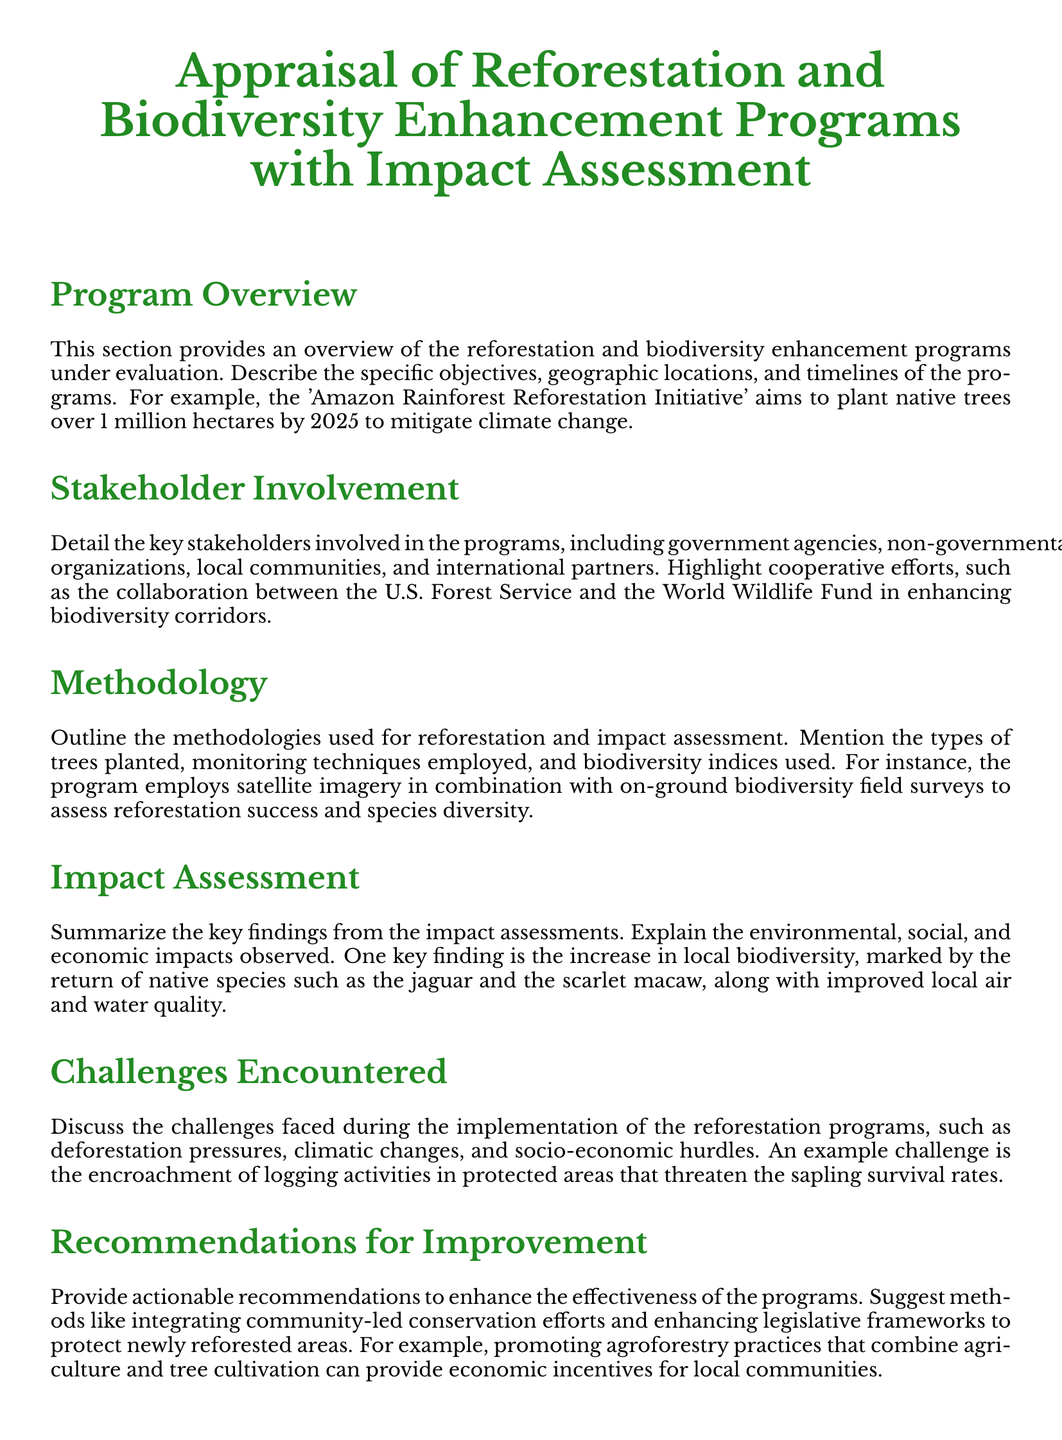What is the main objective of the Amazon Rainforest Reforestation Initiative? The main objective is to plant native trees over 1 million hectares by 2025 to mitigate climate change.
Answer: plant native trees over 1 million hectares by 2025 Who are the stakeholders mentioned in the programs? Key stakeholders include government agencies, non-governmental organizations, local communities, and international partners.
Answer: government agencies, non-governmental organizations, local communities, international partners What methodology involves satellite imagery? The methodology that involves satellite imagery is to assess reforestation success and species diversity.
Answer: assess reforestation success and species diversity Which native species returned as a key finding? The return of native species such as the jaguar and the scarlet macaw was a key finding.
Answer: jaguar and the scarlet macaw What challenge is mentioned regarding logging activities? The challenge mentioned is the encroachment of logging activities in protected areas that threaten sapling survival rates.
Answer: encroachment of logging activities in protected areas What type of farming practice is recommended for local communities? Agroforestry practices that combine agriculture and tree cultivation are recommended.
Answer: Agroforestry practices What is emphasized as important for the programs' success? Sustained efforts and adaptive management are emphasized as important for the programs' success.
Answer: sustained efforts and adaptive management 